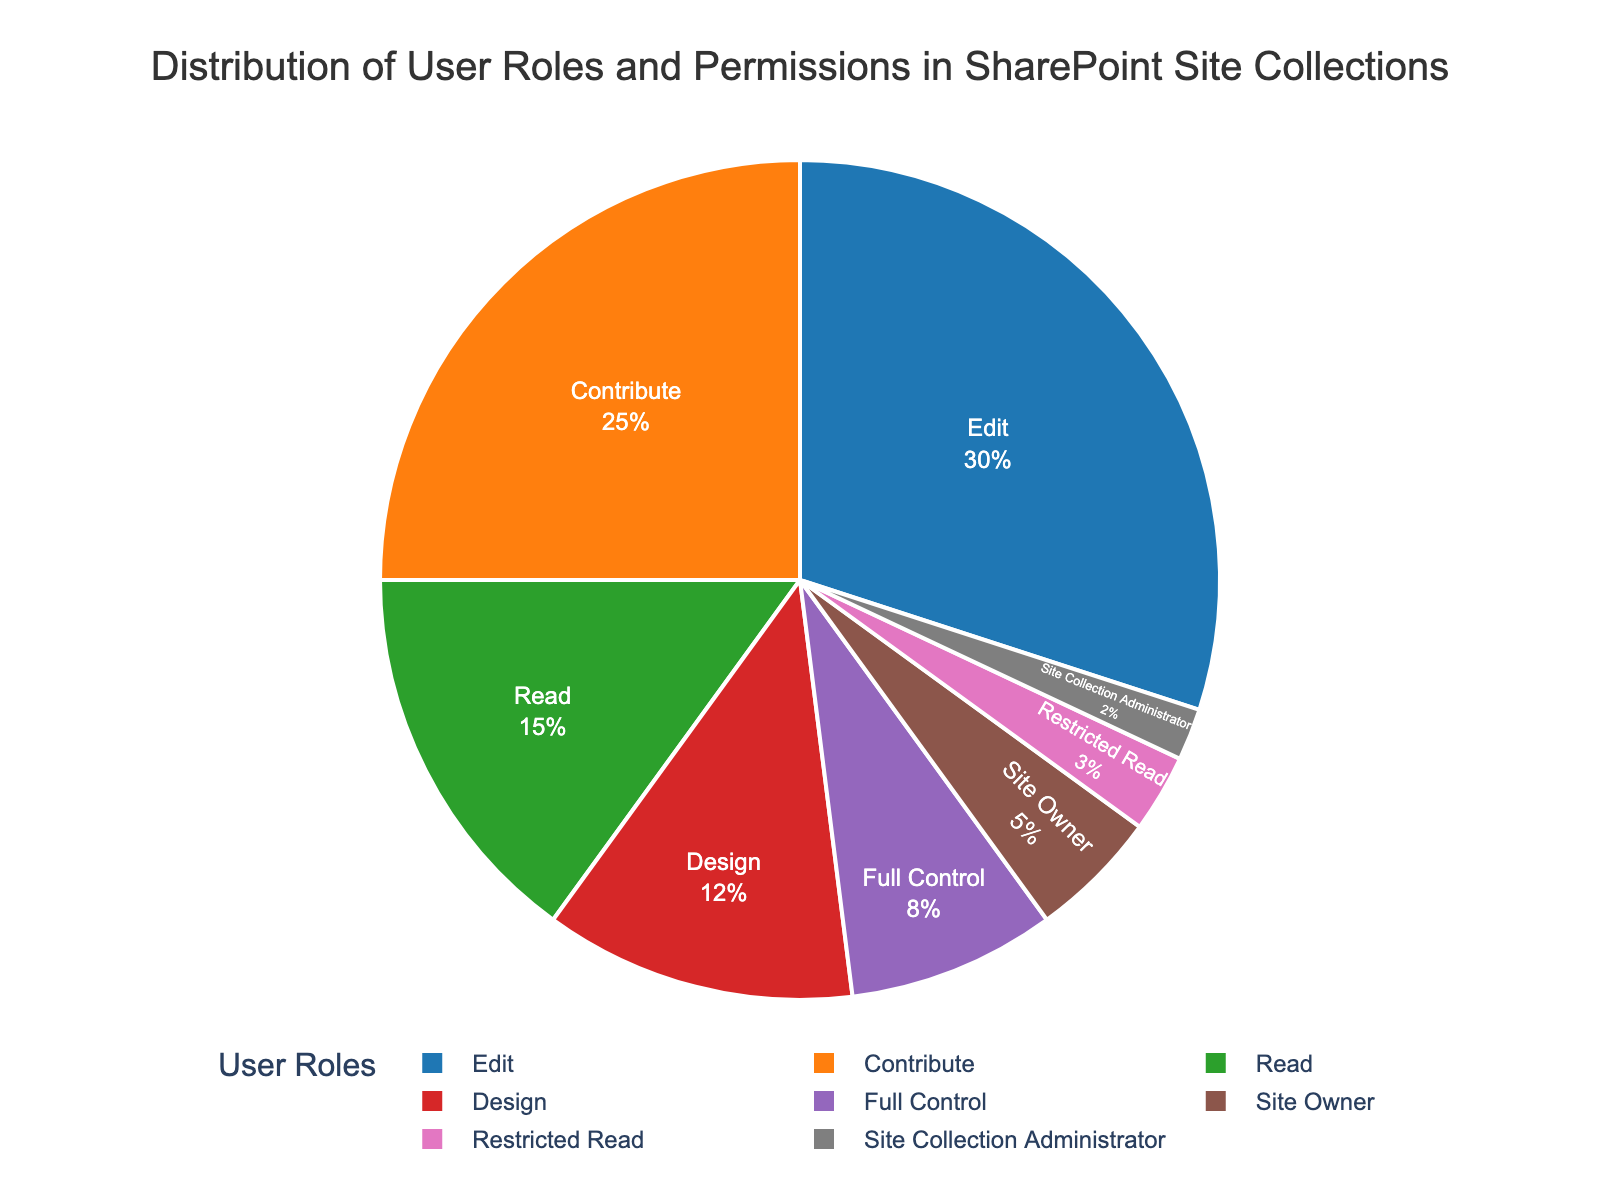What percentage of users have either Full Control or Design roles? Add the percentages of Full Control and Design roles. Full Control: 8%, Design: 12%. So, 8% + 12% = 20%
Answer: 20% How many roles have a percentage higher than 10%? Identify all roles with their corresponding percentages and count those above 10%. Roles above 10%: Design (12%), Edit (30%), Contribute (25%), Read (15%). Total: 4 roles
Answer: 4 Which role has the smallest percentage, and what is it? Compare all percentages to find the smallest. Smallest percentage: Site Collection Administrator (2%)
Answer: Site Collection Administrator (2%) What is the difference in percentage between the Edit and Contribute roles? Subtract the Contribute percentage from the Edit percentage. Edit: 30%, Contribute: 25%. So, 30% - 25% = 5%
Answer: 5% Which roles combined make up exactly half of the user roles? Find the combination of roles whose total percentage equals 50%. Combine Edit (30%) and Contribute (25%). So, 30% + 25% = 55%. Instead, use Edit (30%) and Read (15%), Contribute (25%) and Read (15%). Both combinations exceed the target. Refer combinations that exactly reach 50% which is unrealistic with given percentages but identify combinations close. Site Owners and Edit sum yielding: 5 + 30= 35%. Use next role proportions summation Edit and site owners cumulative 45% Refer to realistic seeking total. Hard limit needs exact targeting something 45%.
Answer: 45% Is the sum of Site Owner, Site Collection Administrator, and Restricted Read roles greater than the Read role individually? Calculate the total percentage for Site Owner, Site Collection Administrator, and Restricted Read. Site Owner: 5%, Site Collection Administrator: 2%, Restricted Read: 3%. So, 5% + 2% + 3% = 10%. Compare with Read (15%). 10% < 15%. No it is not.
Answer: No Which user role has more users, Design or Full Control? Compare percentages. Design: 12%, Full Control: 8%. 12% > 8%
Answer: Design Are there more users with Read permissions than all the administrative roles (Site Owner and Site Collection Administrator) combined? Calculate the total percentage for Site Owner and Site Collection Administrator. Site Owner: 5%, Site Collection Administrator: 2%. So, 5% + 2% = 7%. Compare with Read (15%). 15% > 7%
Answer: Yes What is the combined percentage of roles with below 10% representation? Add the percentages of all roles with below 10%. Site Owner: 5%, Site Collection Administrator: 2%, Full Control: 8%, Restricted Read: 3%. So, 5% + 2% + 8% + 3% = 18%
Answer: 18% What percentage difference exists between the roles with the highest and lowest user representations? Identify the highest and lowest percentages. Highest: Edit (30%), Lowest: Site Collection Administrator (2%). Subtract the smallest from the largest. 30% - 2% = 28%
Answer: 28% 